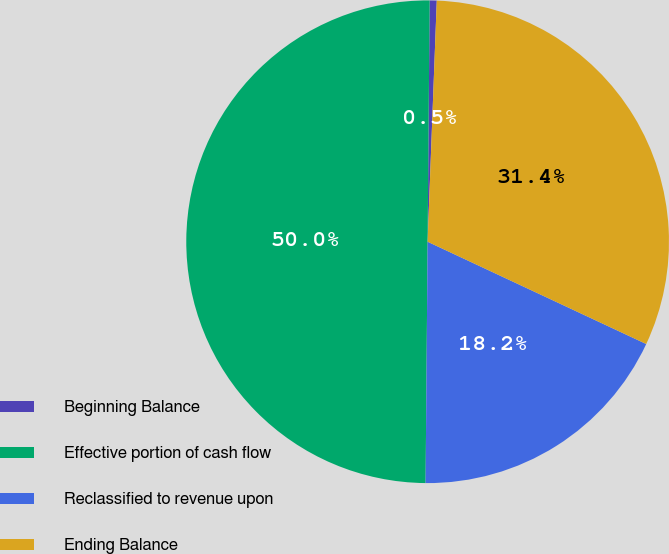Convert chart. <chart><loc_0><loc_0><loc_500><loc_500><pie_chart><fcel>Beginning Balance<fcel>Effective portion of cash flow<fcel>Reclassified to revenue upon<fcel>Ending Balance<nl><fcel>0.47%<fcel>50.0%<fcel>18.17%<fcel>31.36%<nl></chart> 